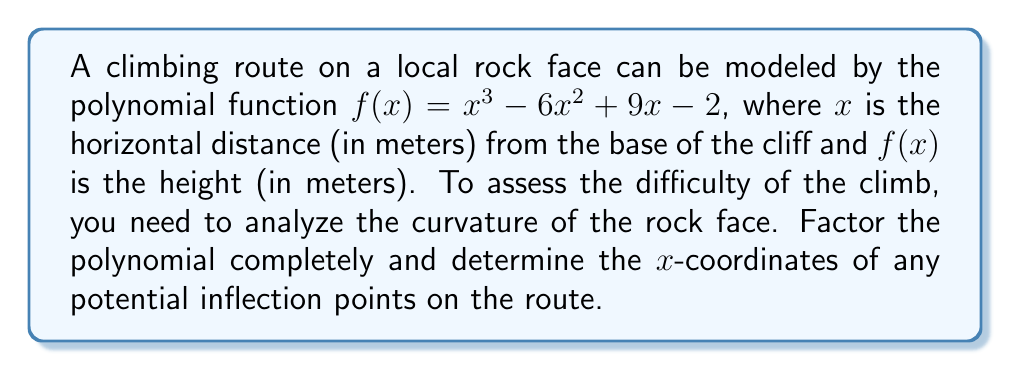Could you help me with this problem? To solve this problem, we'll follow these steps:

1) First, we need to factor the polynomial $f(x) = x^3 - 6x^2 + 9x - 2$.

2) We can start by checking if there's a common factor. In this case, there isn't.

3) Next, we can try to guess a root. One way to do this is to look at the possible factors of the constant term (-2). The factors of -2 are ±1 and ±2. Testing these:

   $f(1) = 1 - 6 + 9 - 2 = 2$
   $f(2) = 8 - 24 + 18 - 2 = 0$

   We find that 2 is a root.

4) Now we can factor out $(x-2)$:

   $f(x) = (x-2)(x^2 - 4x + 1)$

5) The quadratic term $x^2 - 4x + 1$ can be factored further:

   $x^2 - 4x + 1 = (x-2)^2 - 3 = (x-2-\sqrt{3})(x-2+\sqrt{3})$

6) Therefore, the fully factored polynomial is:

   $f(x) = (x-2)(x-2-\sqrt{3})(x-2+\sqrt{3})$

7) To find potential inflection points, we need to find where the second derivative equals zero. The second derivative of a cubic function is a linear function, so it will have at most one root.

8) The second derivative of $f(x) = x^3 - 6x^2 + 9x - 2$ is:

   $f''(x) = 6x - 12 = 6(x-2)$

9) Setting this equal to zero:

   $6(x-2) = 0$
   $x-2 = 0$
   $x = 2$

Therefore, the potential inflection point occurs at $x = 2$, which coincides with one of the roots of the original function.
Answer: The polynomial factors as $f(x) = (x-2)(x-2-\sqrt{3})(x-2+\sqrt{3})$, and the potential inflection point occurs at $x = 2$ meters from the base of the cliff. 